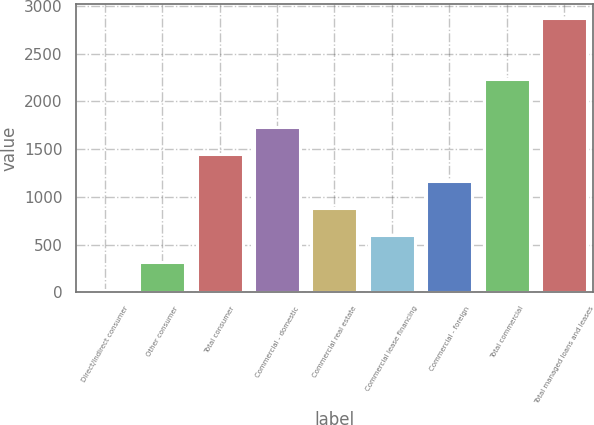Convert chart. <chart><loc_0><loc_0><loc_500><loc_500><bar_chart><fcel>Direct/Indirect consumer<fcel>Other consumer<fcel>Total consumer<fcel>Commercial - domestic<fcel>Commercial real estate<fcel>Commercial lease financing<fcel>Commercial - foreign<fcel>Total commercial<fcel>Total managed loans and leases<nl><fcel>28<fcel>312.4<fcel>1450<fcel>1734.4<fcel>881.2<fcel>596.8<fcel>1165.6<fcel>2234<fcel>2872<nl></chart> 